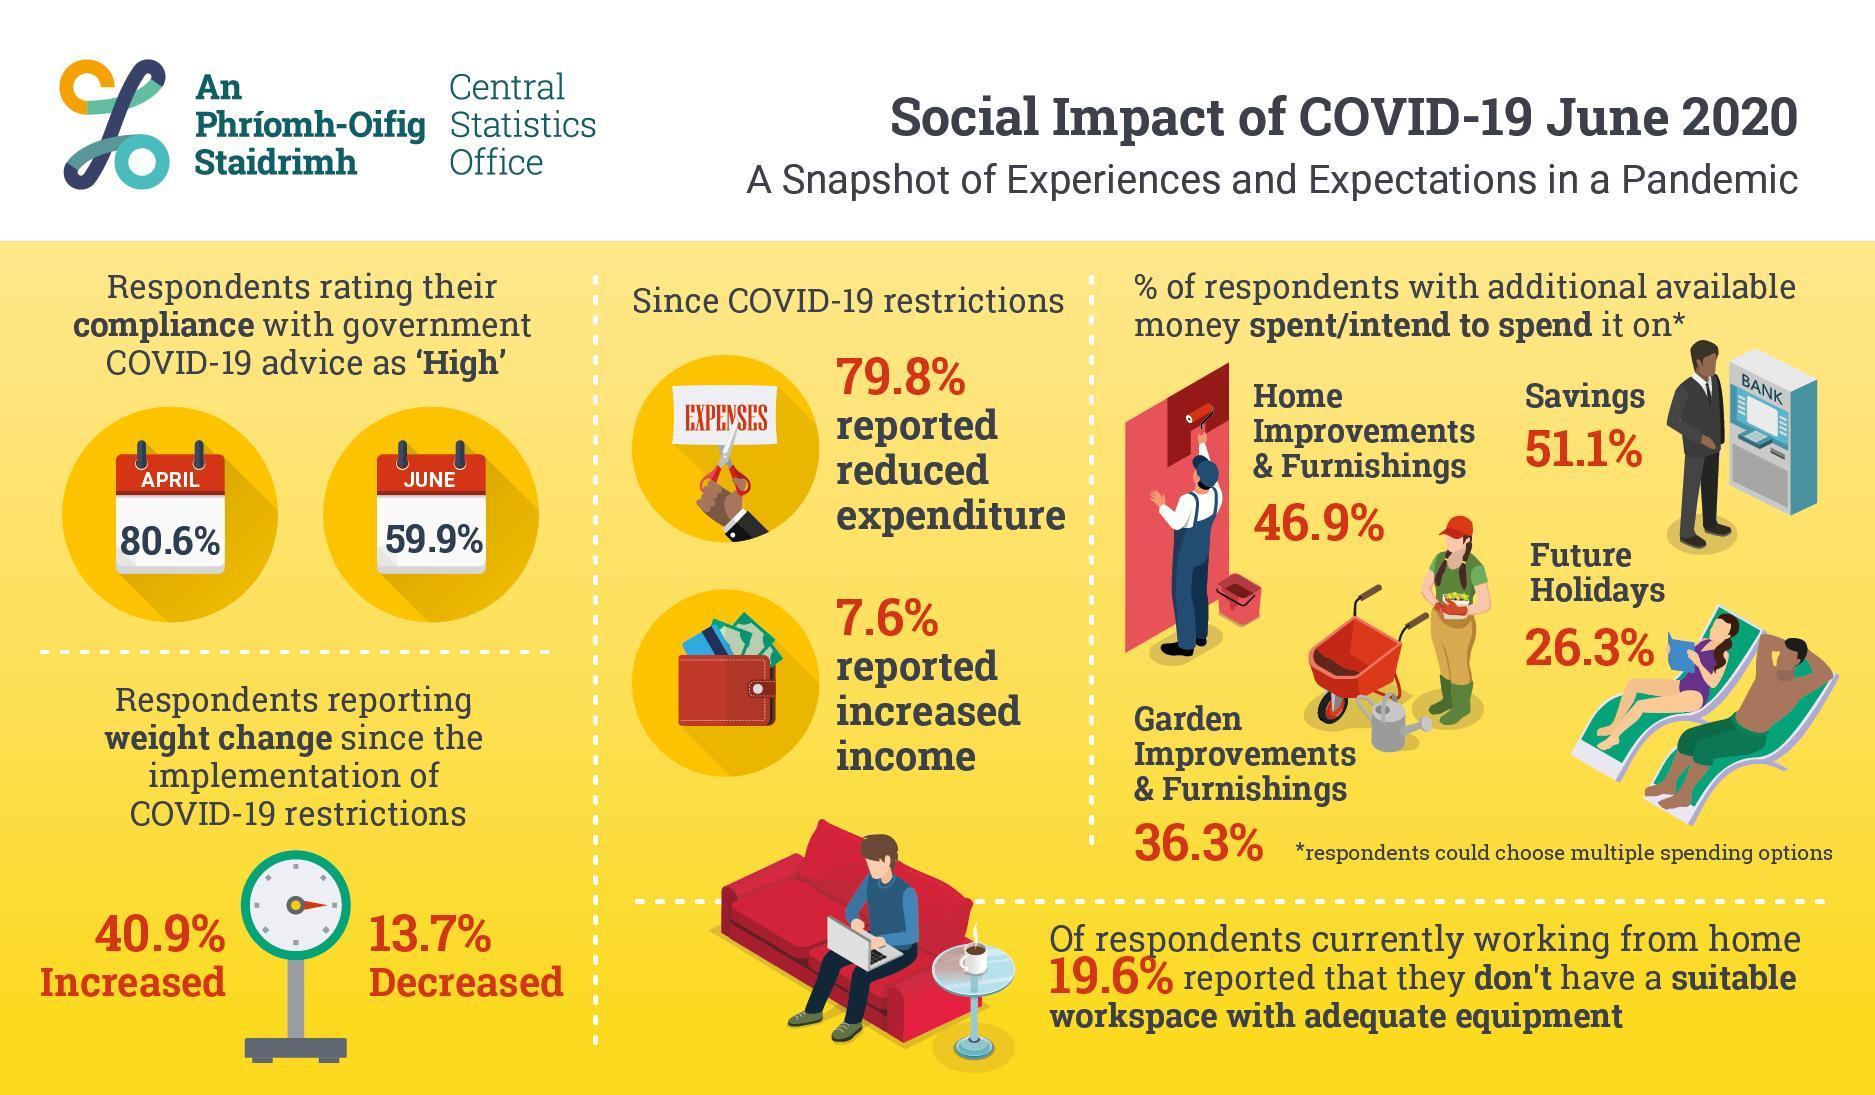What percentage of people believe their salary is more saved due to Covid-19 restrictions?
Answer the question with a short phrase. 7.6% What percentage of people comply with the government restrictions in June? 59.9% How many people lose their body mass due to the lock down? 13.7% What is the decrease in no of people who comply with the government from April to June? 20.7 What percentage of people are going to put saved money into vacations? 26.3% How many people put on extra body mass due to the lockdown? 40.9% What percentage of people are going to put saved money into reserves? 51.1% What is the inverse percentage of people who believe their spending got decreased due to Covid-19 restrictions? 20.2 